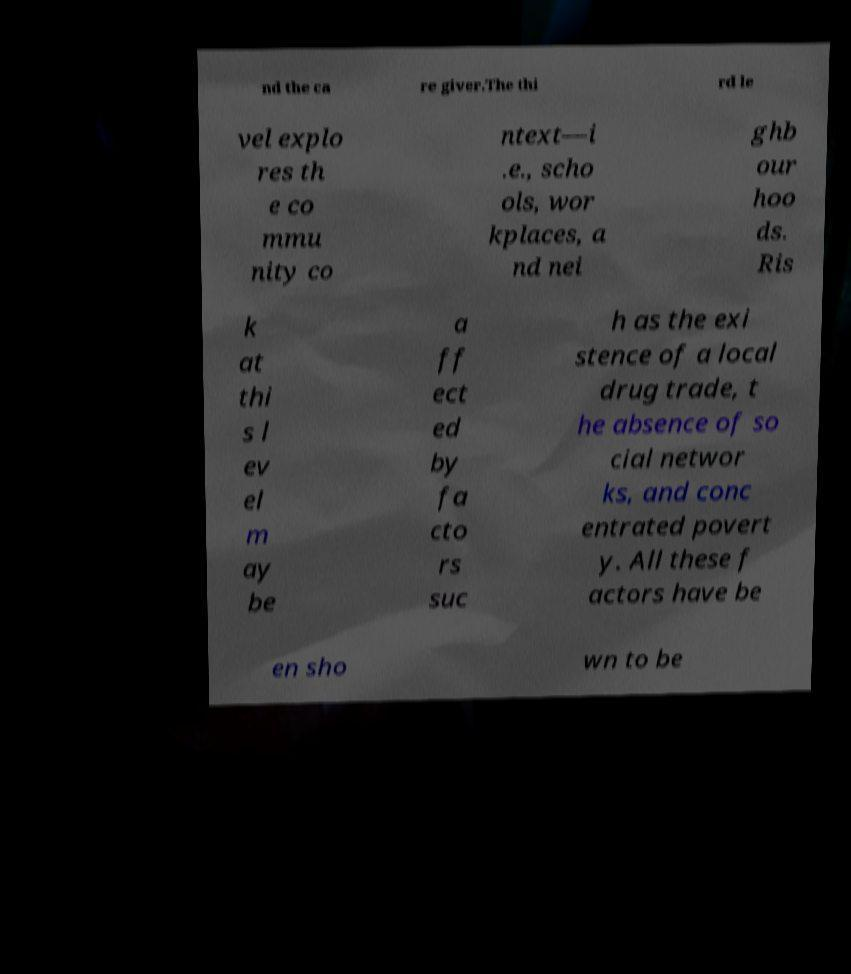There's text embedded in this image that I need extracted. Can you transcribe it verbatim? nd the ca re giver.The thi rd le vel explo res th e co mmu nity co ntext—i .e., scho ols, wor kplaces, a nd nei ghb our hoo ds. Ris k at thi s l ev el m ay be a ff ect ed by fa cto rs suc h as the exi stence of a local drug trade, t he absence of so cial networ ks, and conc entrated povert y. All these f actors have be en sho wn to be 